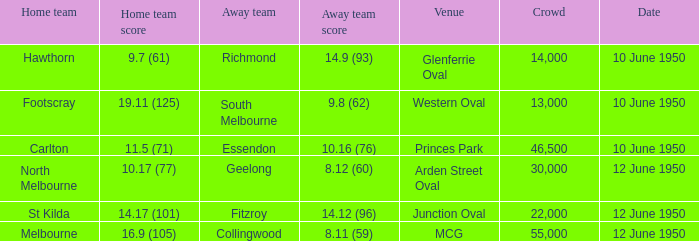What was the assembly when melbourne was the home side? 55000.0. 